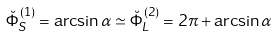<formula> <loc_0><loc_0><loc_500><loc_500>\breve { \Phi } ^ { ( 1 ) } _ { S } = \arcsin \alpha \simeq \breve { \Phi } ^ { ( 2 ) } _ { L } = 2 \pi + \arcsin \alpha</formula> 